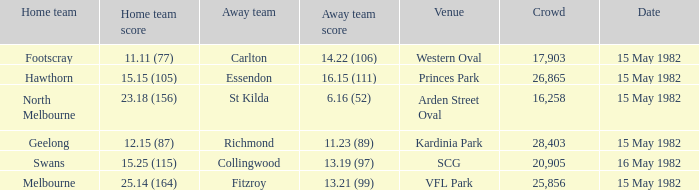Which home team played against the away team with a score of 13.19 (97)? Swans. 